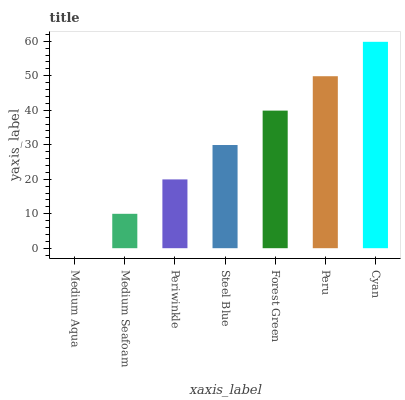Is Medium Aqua the minimum?
Answer yes or no. Yes. Is Cyan the maximum?
Answer yes or no. Yes. Is Medium Seafoam the minimum?
Answer yes or no. No. Is Medium Seafoam the maximum?
Answer yes or no. No. Is Medium Seafoam greater than Medium Aqua?
Answer yes or no. Yes. Is Medium Aqua less than Medium Seafoam?
Answer yes or no. Yes. Is Medium Aqua greater than Medium Seafoam?
Answer yes or no. No. Is Medium Seafoam less than Medium Aqua?
Answer yes or no. No. Is Steel Blue the high median?
Answer yes or no. Yes. Is Steel Blue the low median?
Answer yes or no. Yes. Is Peru the high median?
Answer yes or no. No. Is Peru the low median?
Answer yes or no. No. 